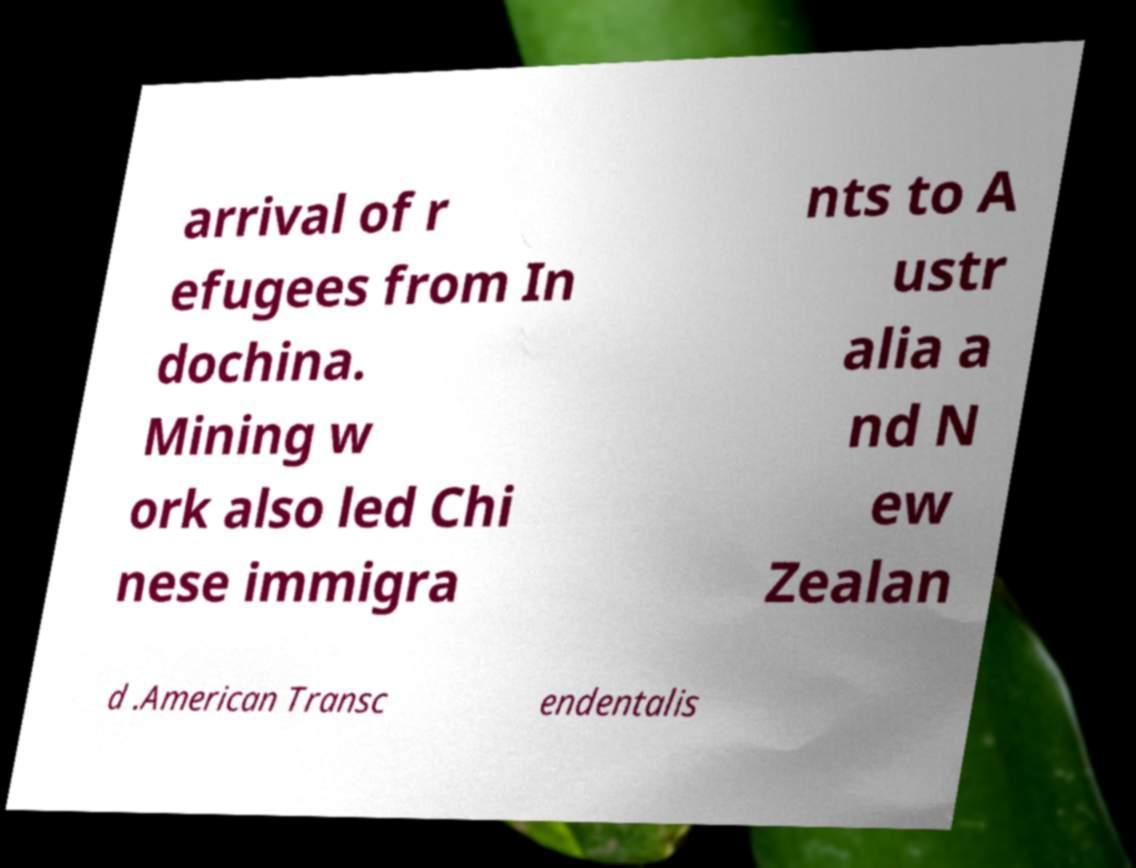For documentation purposes, I need the text within this image transcribed. Could you provide that? arrival of r efugees from In dochina. Mining w ork also led Chi nese immigra nts to A ustr alia a nd N ew Zealan d .American Transc endentalis 